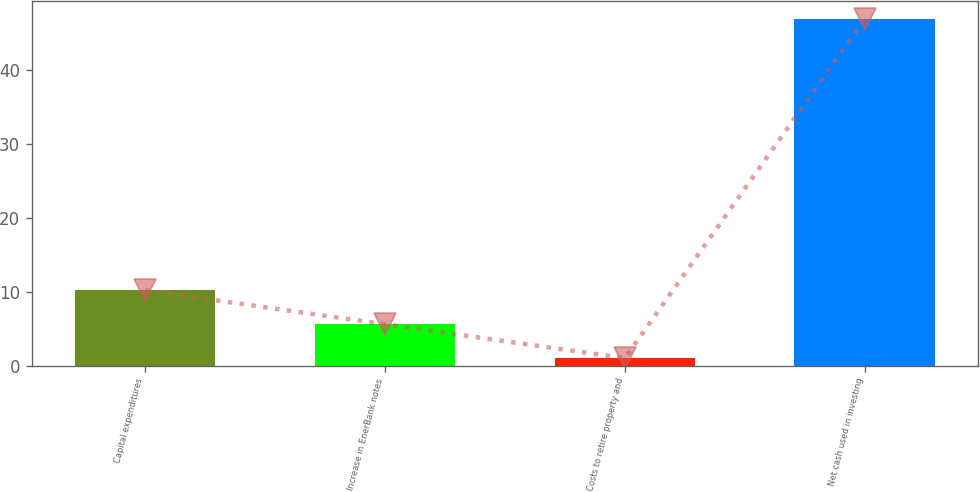Convert chart to OTSL. <chart><loc_0><loc_0><loc_500><loc_500><bar_chart><fcel>Capital expenditures<fcel>Increase in EnerBank notes<fcel>Costs to retire property and<fcel>Net cash used in investing<nl><fcel>10.2<fcel>5.6<fcel>1<fcel>47<nl></chart> 